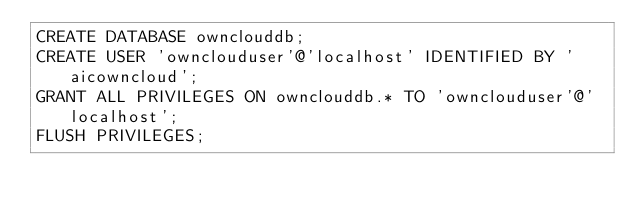<code> <loc_0><loc_0><loc_500><loc_500><_SQL_>CREATE DATABASE ownclouddb;
CREATE USER 'ownclouduser'@'localhost' IDENTIFIED BY 'aicowncloud';
GRANT ALL PRIVILEGES ON ownclouddb.* TO 'ownclouduser'@'localhost';
FLUSH PRIVILEGES;</code> 